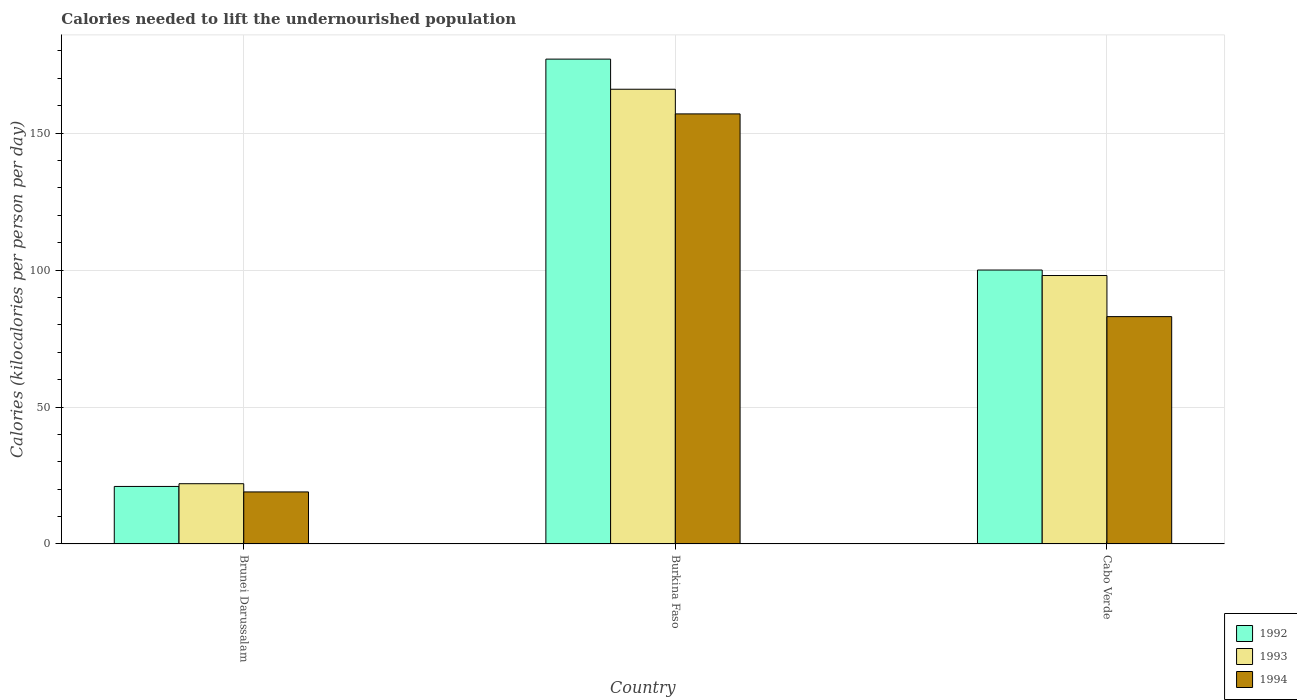How many groups of bars are there?
Give a very brief answer. 3. Are the number of bars on each tick of the X-axis equal?
Give a very brief answer. Yes. How many bars are there on the 3rd tick from the right?
Your response must be concise. 3. What is the label of the 1st group of bars from the left?
Make the answer very short. Brunei Darussalam. In how many cases, is the number of bars for a given country not equal to the number of legend labels?
Offer a very short reply. 0. Across all countries, what is the maximum total calories needed to lift the undernourished population in 1993?
Offer a very short reply. 166. In which country was the total calories needed to lift the undernourished population in 1993 maximum?
Ensure brevity in your answer.  Burkina Faso. In which country was the total calories needed to lift the undernourished population in 1992 minimum?
Make the answer very short. Brunei Darussalam. What is the total total calories needed to lift the undernourished population in 1993 in the graph?
Make the answer very short. 286. What is the difference between the total calories needed to lift the undernourished population in 1994 in Brunei Darussalam and that in Burkina Faso?
Offer a very short reply. -138. What is the difference between the total calories needed to lift the undernourished population in 1993 in Cabo Verde and the total calories needed to lift the undernourished population in 1992 in Brunei Darussalam?
Offer a very short reply. 77. What is the average total calories needed to lift the undernourished population in 1993 per country?
Your response must be concise. 95.33. What is the difference between the total calories needed to lift the undernourished population of/in 1993 and total calories needed to lift the undernourished population of/in 1994 in Burkina Faso?
Provide a short and direct response. 9. What is the ratio of the total calories needed to lift the undernourished population in 1992 in Brunei Darussalam to that in Burkina Faso?
Provide a succinct answer. 0.12. What is the difference between the highest and the second highest total calories needed to lift the undernourished population in 1994?
Provide a succinct answer. -64. What is the difference between the highest and the lowest total calories needed to lift the undernourished population in 1993?
Offer a terse response. 144. In how many countries, is the total calories needed to lift the undernourished population in 1992 greater than the average total calories needed to lift the undernourished population in 1992 taken over all countries?
Your answer should be compact. 2. Is the sum of the total calories needed to lift the undernourished population in 1992 in Brunei Darussalam and Burkina Faso greater than the maximum total calories needed to lift the undernourished population in 1994 across all countries?
Your response must be concise. Yes. What does the 3rd bar from the left in Brunei Darussalam represents?
Your answer should be compact. 1994. What does the 1st bar from the right in Cabo Verde represents?
Offer a very short reply. 1994. How many bars are there?
Provide a short and direct response. 9. How many countries are there in the graph?
Your answer should be compact. 3. What is the difference between two consecutive major ticks on the Y-axis?
Offer a terse response. 50. Does the graph contain any zero values?
Make the answer very short. No. Does the graph contain grids?
Your response must be concise. Yes. Where does the legend appear in the graph?
Ensure brevity in your answer.  Bottom right. How many legend labels are there?
Provide a succinct answer. 3. How are the legend labels stacked?
Your answer should be very brief. Vertical. What is the title of the graph?
Offer a terse response. Calories needed to lift the undernourished population. Does "1975" appear as one of the legend labels in the graph?
Your answer should be very brief. No. What is the label or title of the Y-axis?
Your answer should be compact. Calories (kilocalories per person per day). What is the Calories (kilocalories per person per day) in 1992 in Brunei Darussalam?
Give a very brief answer. 21. What is the Calories (kilocalories per person per day) of 1993 in Brunei Darussalam?
Provide a succinct answer. 22. What is the Calories (kilocalories per person per day) of 1994 in Brunei Darussalam?
Offer a terse response. 19. What is the Calories (kilocalories per person per day) in 1992 in Burkina Faso?
Give a very brief answer. 177. What is the Calories (kilocalories per person per day) of 1993 in Burkina Faso?
Make the answer very short. 166. What is the Calories (kilocalories per person per day) in 1994 in Burkina Faso?
Give a very brief answer. 157. What is the Calories (kilocalories per person per day) of 1992 in Cabo Verde?
Make the answer very short. 100. What is the Calories (kilocalories per person per day) in 1993 in Cabo Verde?
Provide a succinct answer. 98. Across all countries, what is the maximum Calories (kilocalories per person per day) in 1992?
Give a very brief answer. 177. Across all countries, what is the maximum Calories (kilocalories per person per day) of 1993?
Your answer should be very brief. 166. Across all countries, what is the maximum Calories (kilocalories per person per day) of 1994?
Make the answer very short. 157. Across all countries, what is the minimum Calories (kilocalories per person per day) of 1993?
Ensure brevity in your answer.  22. Across all countries, what is the minimum Calories (kilocalories per person per day) of 1994?
Provide a succinct answer. 19. What is the total Calories (kilocalories per person per day) in 1992 in the graph?
Your answer should be compact. 298. What is the total Calories (kilocalories per person per day) in 1993 in the graph?
Your response must be concise. 286. What is the total Calories (kilocalories per person per day) of 1994 in the graph?
Provide a short and direct response. 259. What is the difference between the Calories (kilocalories per person per day) of 1992 in Brunei Darussalam and that in Burkina Faso?
Offer a terse response. -156. What is the difference between the Calories (kilocalories per person per day) in 1993 in Brunei Darussalam and that in Burkina Faso?
Your response must be concise. -144. What is the difference between the Calories (kilocalories per person per day) of 1994 in Brunei Darussalam and that in Burkina Faso?
Provide a succinct answer. -138. What is the difference between the Calories (kilocalories per person per day) of 1992 in Brunei Darussalam and that in Cabo Verde?
Provide a succinct answer. -79. What is the difference between the Calories (kilocalories per person per day) in 1993 in Brunei Darussalam and that in Cabo Verde?
Give a very brief answer. -76. What is the difference between the Calories (kilocalories per person per day) in 1994 in Brunei Darussalam and that in Cabo Verde?
Provide a short and direct response. -64. What is the difference between the Calories (kilocalories per person per day) of 1992 in Burkina Faso and that in Cabo Verde?
Keep it short and to the point. 77. What is the difference between the Calories (kilocalories per person per day) in 1993 in Burkina Faso and that in Cabo Verde?
Your response must be concise. 68. What is the difference between the Calories (kilocalories per person per day) in 1992 in Brunei Darussalam and the Calories (kilocalories per person per day) in 1993 in Burkina Faso?
Offer a terse response. -145. What is the difference between the Calories (kilocalories per person per day) in 1992 in Brunei Darussalam and the Calories (kilocalories per person per day) in 1994 in Burkina Faso?
Keep it short and to the point. -136. What is the difference between the Calories (kilocalories per person per day) of 1993 in Brunei Darussalam and the Calories (kilocalories per person per day) of 1994 in Burkina Faso?
Give a very brief answer. -135. What is the difference between the Calories (kilocalories per person per day) of 1992 in Brunei Darussalam and the Calories (kilocalories per person per day) of 1993 in Cabo Verde?
Your answer should be compact. -77. What is the difference between the Calories (kilocalories per person per day) in 1992 in Brunei Darussalam and the Calories (kilocalories per person per day) in 1994 in Cabo Verde?
Provide a short and direct response. -62. What is the difference between the Calories (kilocalories per person per day) in 1993 in Brunei Darussalam and the Calories (kilocalories per person per day) in 1994 in Cabo Verde?
Make the answer very short. -61. What is the difference between the Calories (kilocalories per person per day) of 1992 in Burkina Faso and the Calories (kilocalories per person per day) of 1993 in Cabo Verde?
Make the answer very short. 79. What is the difference between the Calories (kilocalories per person per day) of 1992 in Burkina Faso and the Calories (kilocalories per person per day) of 1994 in Cabo Verde?
Your response must be concise. 94. What is the average Calories (kilocalories per person per day) in 1992 per country?
Ensure brevity in your answer.  99.33. What is the average Calories (kilocalories per person per day) in 1993 per country?
Offer a terse response. 95.33. What is the average Calories (kilocalories per person per day) in 1994 per country?
Your answer should be compact. 86.33. What is the difference between the Calories (kilocalories per person per day) of 1992 and Calories (kilocalories per person per day) of 1994 in Brunei Darussalam?
Provide a short and direct response. 2. What is the difference between the Calories (kilocalories per person per day) of 1992 and Calories (kilocalories per person per day) of 1993 in Burkina Faso?
Provide a succinct answer. 11. What is the difference between the Calories (kilocalories per person per day) of 1992 and Calories (kilocalories per person per day) of 1994 in Burkina Faso?
Ensure brevity in your answer.  20. What is the difference between the Calories (kilocalories per person per day) of 1993 and Calories (kilocalories per person per day) of 1994 in Burkina Faso?
Offer a terse response. 9. What is the difference between the Calories (kilocalories per person per day) of 1992 and Calories (kilocalories per person per day) of 1993 in Cabo Verde?
Your response must be concise. 2. What is the difference between the Calories (kilocalories per person per day) in 1993 and Calories (kilocalories per person per day) in 1994 in Cabo Verde?
Ensure brevity in your answer.  15. What is the ratio of the Calories (kilocalories per person per day) in 1992 in Brunei Darussalam to that in Burkina Faso?
Provide a succinct answer. 0.12. What is the ratio of the Calories (kilocalories per person per day) in 1993 in Brunei Darussalam to that in Burkina Faso?
Provide a short and direct response. 0.13. What is the ratio of the Calories (kilocalories per person per day) in 1994 in Brunei Darussalam to that in Burkina Faso?
Make the answer very short. 0.12. What is the ratio of the Calories (kilocalories per person per day) in 1992 in Brunei Darussalam to that in Cabo Verde?
Give a very brief answer. 0.21. What is the ratio of the Calories (kilocalories per person per day) in 1993 in Brunei Darussalam to that in Cabo Verde?
Provide a succinct answer. 0.22. What is the ratio of the Calories (kilocalories per person per day) in 1994 in Brunei Darussalam to that in Cabo Verde?
Ensure brevity in your answer.  0.23. What is the ratio of the Calories (kilocalories per person per day) in 1992 in Burkina Faso to that in Cabo Verde?
Provide a succinct answer. 1.77. What is the ratio of the Calories (kilocalories per person per day) in 1993 in Burkina Faso to that in Cabo Verde?
Keep it short and to the point. 1.69. What is the ratio of the Calories (kilocalories per person per day) in 1994 in Burkina Faso to that in Cabo Verde?
Give a very brief answer. 1.89. What is the difference between the highest and the second highest Calories (kilocalories per person per day) of 1992?
Your answer should be compact. 77. What is the difference between the highest and the second highest Calories (kilocalories per person per day) in 1994?
Your answer should be compact. 74. What is the difference between the highest and the lowest Calories (kilocalories per person per day) in 1992?
Your answer should be compact. 156. What is the difference between the highest and the lowest Calories (kilocalories per person per day) in 1993?
Your answer should be very brief. 144. What is the difference between the highest and the lowest Calories (kilocalories per person per day) in 1994?
Your response must be concise. 138. 